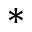Convert formula to latex. <formula><loc_0><loc_0><loc_500><loc_500>\ast</formula> 